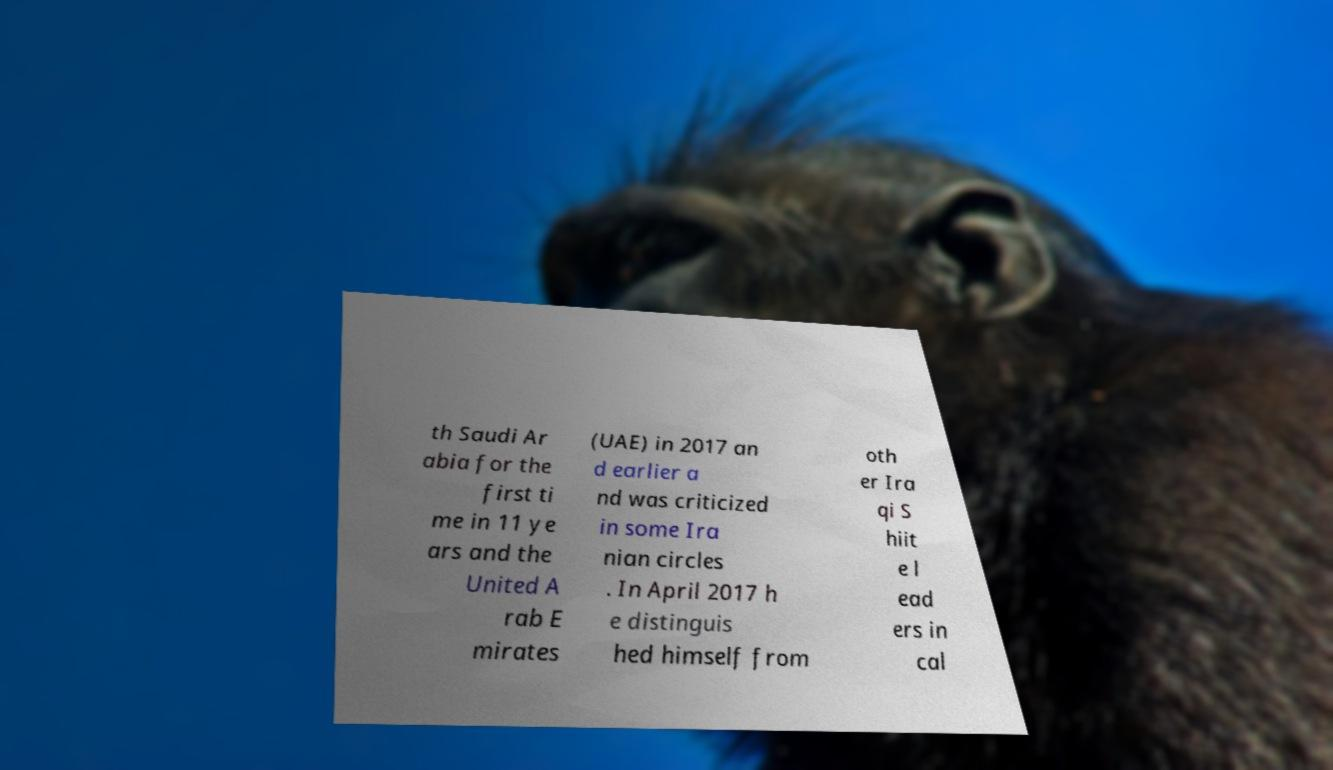Please identify and transcribe the text found in this image. th Saudi Ar abia for the first ti me in 11 ye ars and the United A rab E mirates (UAE) in 2017 an d earlier a nd was criticized in some Ira nian circles . In April 2017 h e distinguis hed himself from oth er Ira qi S hiit e l ead ers in cal 